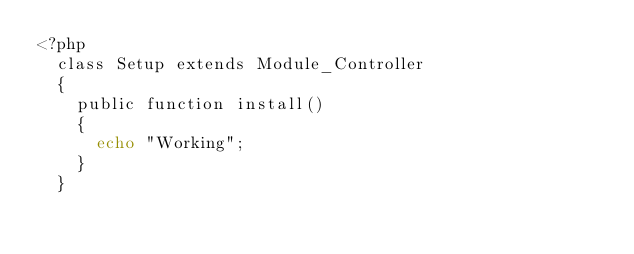<code> <loc_0><loc_0><loc_500><loc_500><_PHP_><?php
	class Setup extends Module_Controller
	{
		public function install()
		{
			echo "Working";
		}
	}</code> 